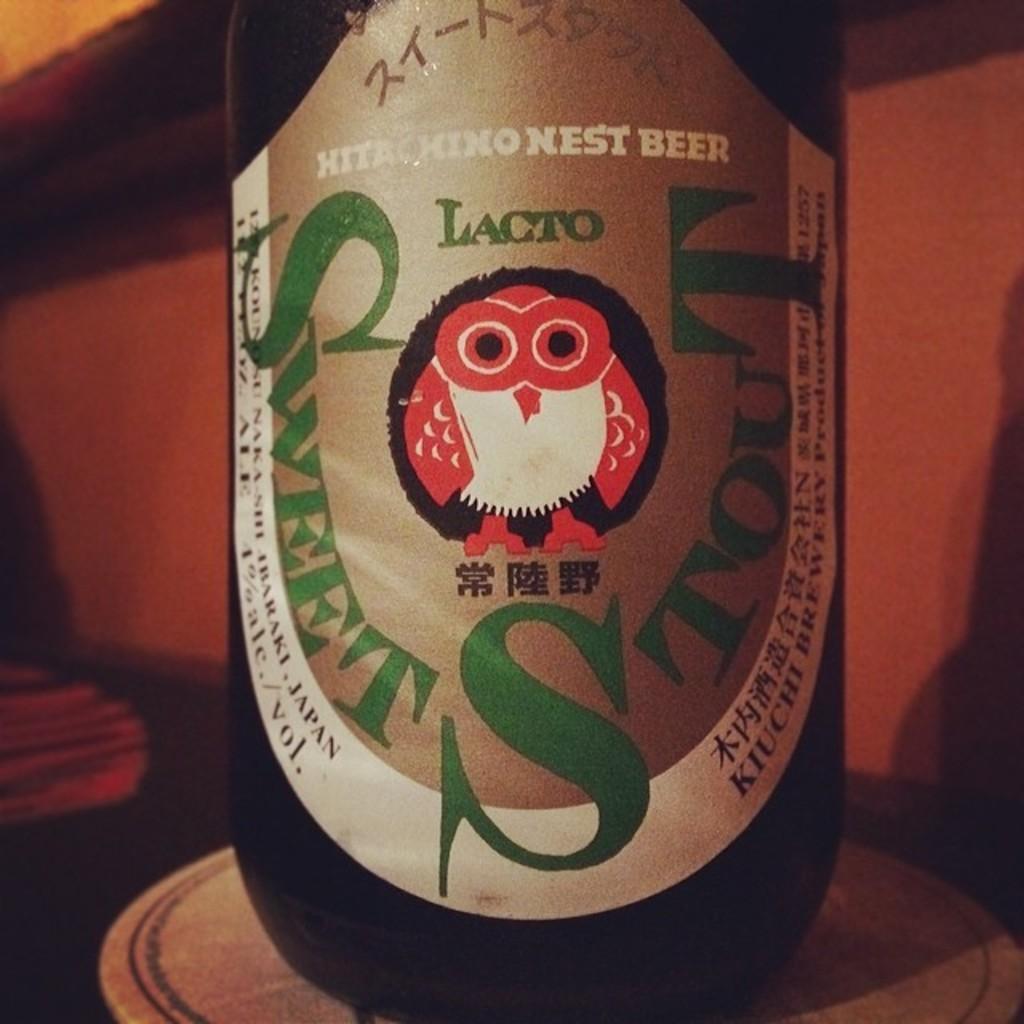Could you give a brief overview of what you see in this image? In this image I can see there is a sticker on a beer bottle. In the middle it is in the shape of an owl in red color and white color. 